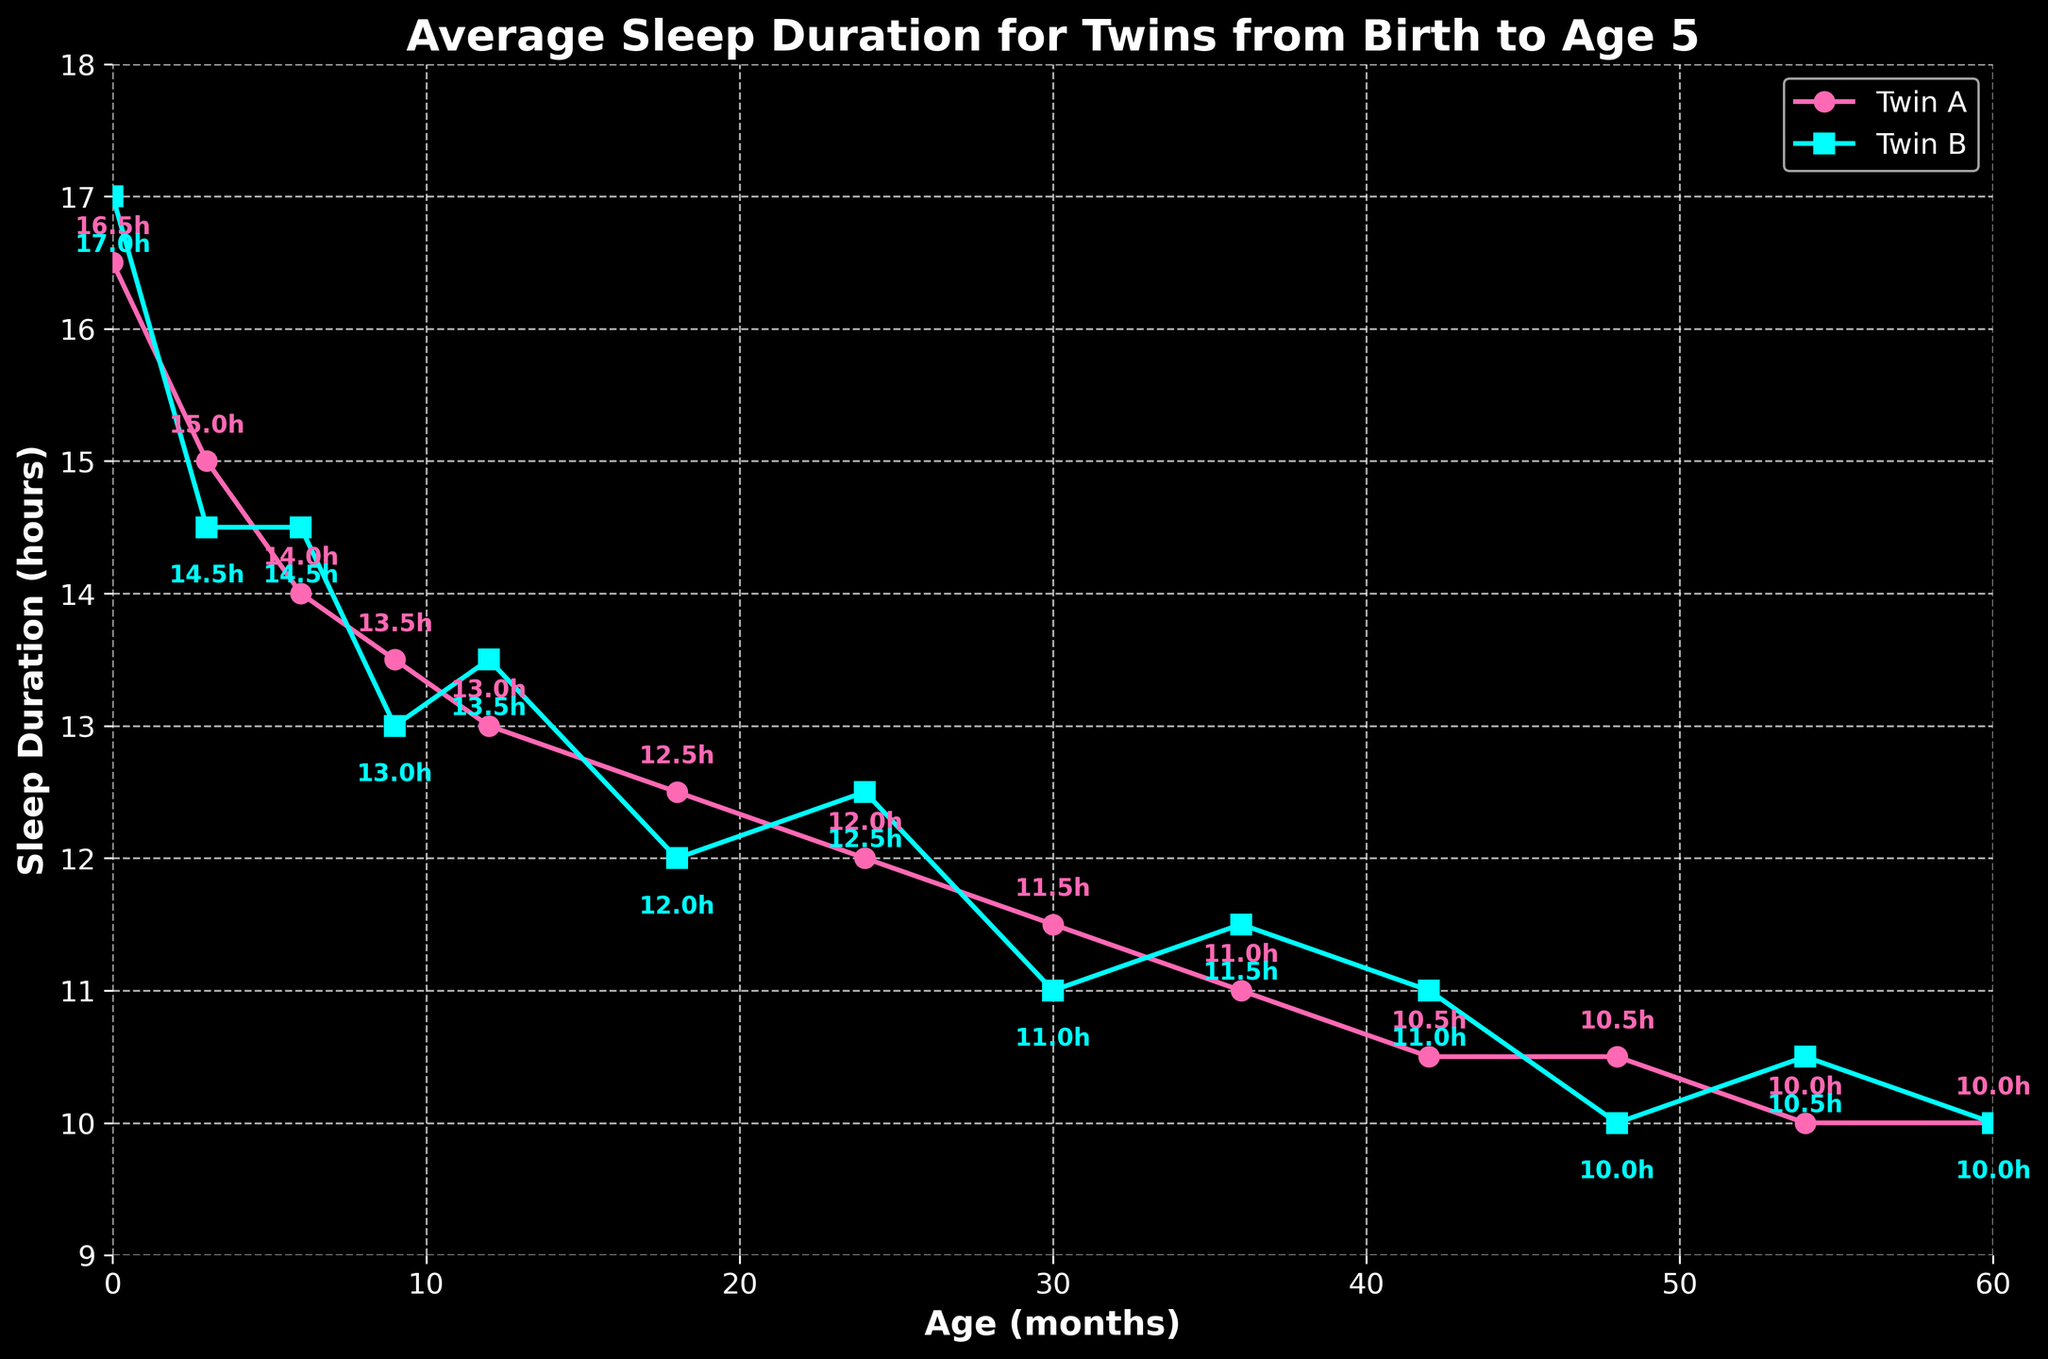What is the sleep duration difference between Twin A and Twin B at 0 months? At 0 months, Twin A sleeps 16.5 hours and Twin B sleeps 17.0 hours. The difference is calculated as 17.0 - 16.5.
Answer: 0.5 hours Who sleeps more on average by age 60 months, Twin A or Twin B? By age 60 months, both twins sleep 10.0 hours each as shown on the graph. Therefore, neither twin sleeps more than the other.
Answer: Neither Twin What is the average sleep duration for Twin A over the entire period? To find the average sleep duration for Twin A, we sum up all sleep durations and divide by the number of data points. So, (16.5 + 15.0 + 14.0 + 13.5 + 13.0 + 12.5 + 12.0 + 11.5 + 11.0 + 10.5 + 10.5 + 10.0 + 10.0) / 13 = 12.38 hours.
Answer: 12.38 hours At which age does Twin B's sleep duration peak? The peak is the highest point on Twin B's plot line. Twin B's sleep duration peaks at 0 months, where it is 17.0 hours.
Answer: 0 months Between 9 and 24 months, does Twin A's sleep duration increase, decrease, or stay stable? Twin A's sleep duration decreases from 13.5 hours at 9 months to 12.0 hours at 24 months, showing a declining trend.
Answer: Decrease What is the cumulative sleep duration of Twin B at ages 36 months and 54 months? At 36 months, Twin B sleeps 11.5 hours and at 54 months, Twin B sleeps 10.5 hours. The cumulative duration is 11.5 + 10.5 = 22.0 hours.
Answer: 22.0 hours Who has the longest sleep duration at 18 months? By checking the graph at the 18-month mark, Twin A has a sleep duration of 12.5 hours and Twin B has 12.0 hours. Twin A has the longest sleep duration at this age.
Answer: Twin A What is the range of sleep durations for Twin A? The range is the difference between the maximum and minimum sleep durations of Twin A. Maximum is 16.5 hours and minimum is 10.0 hours. Therefore, the range is 16.5 - 10.0 = 6.5 hours.
Answer: 6.5 hours Does the sleep duration difference between the twins grow larger or smaller over time? Initially at 0 months, the difference is 0.5 hours. By examining the subsequent data points, we see that the differences fluctuate but generally stay within a small range (±0.5 hours), suggesting it neither consistently grows larger nor smaller.
Answer: Neither At what age do both twins have the same sleep duration again after 0 months? The first age after 0 months where the sleep durations are equal is at 60 months, with both sleeping 10.0 hours.
Answer: 60 months 